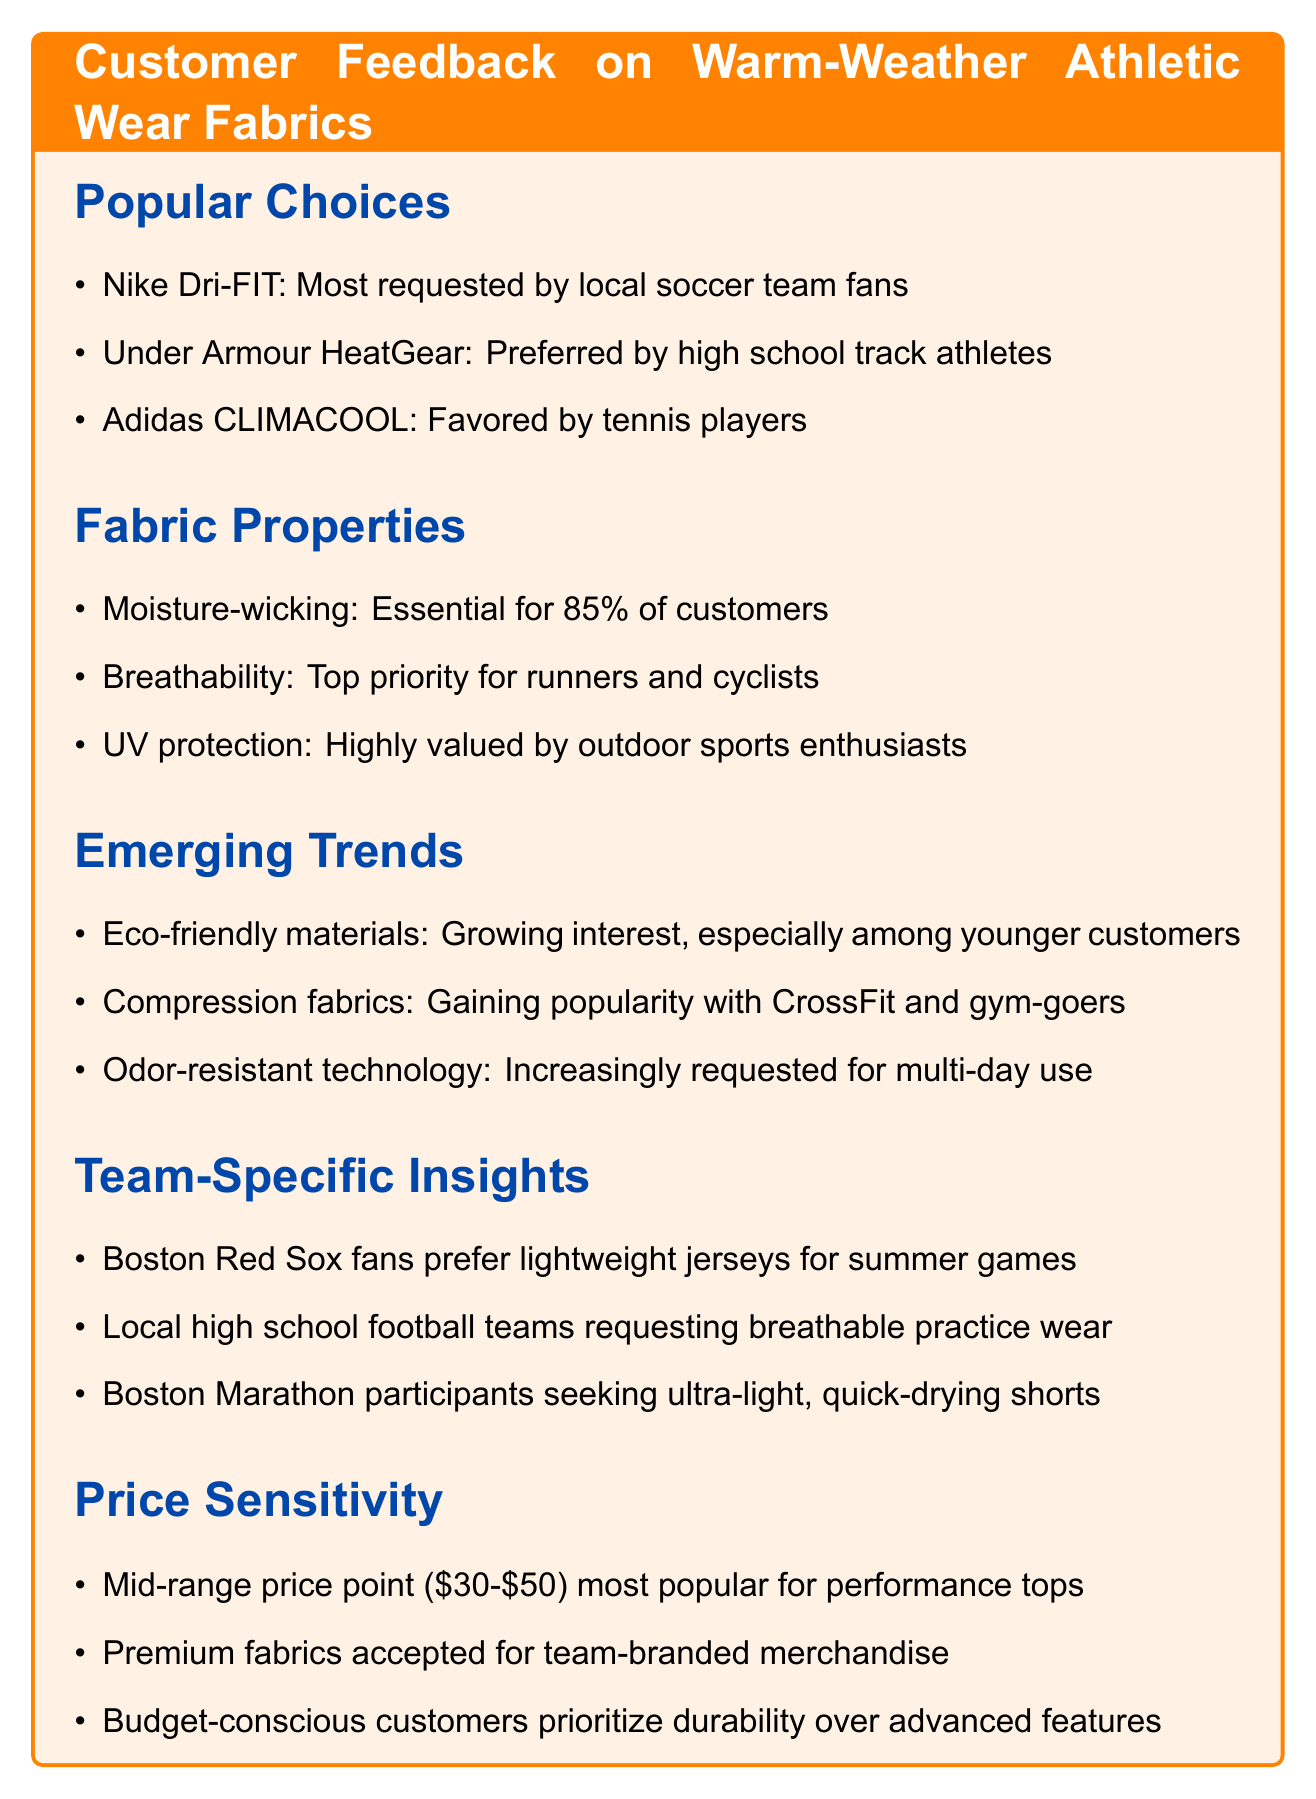What fabric is most requested by local soccer team fans? The document states that Nike Dri-FIT is the most requested fabric by local soccer team fans.
Answer: Nike Dri-FIT Which fabric property is essential for 85% of customers? The document notes that moisture-wicking is essential for 85% of customers.
Answer: Moisture-wicking What is a growing trend among younger customers? The document mentions a growing interest in eco-friendly materials among younger customers.
Answer: Eco-friendly materials What do Boston Marathon participants seek in athletic wear? The document indicates that Boston Marathon participants seek ultra-light, quick-drying shorts.
Answer: Ultra-light, quick-drying shorts What is the most popular price point for performance tops? The document states that the mid-range price point of $30-$50 is the most popular for performance tops.
Answer: $30-$50 What type of fabric is gaining popularity with CrossFit and gym-goers? The document mentions that compression fabrics are gaining popularity with CrossFit and gym-goers.
Answer: Compression fabrics Which fabric is preferred by high school track athletes? According to the document, Under Armour HeatGear is preferred by high school track athletes.
Answer: Under Armour HeatGear What do budget-conscious customers prioritize over advanced features? The document explains that budget-conscious customers prioritize durability over advanced features.
Answer: Durability 